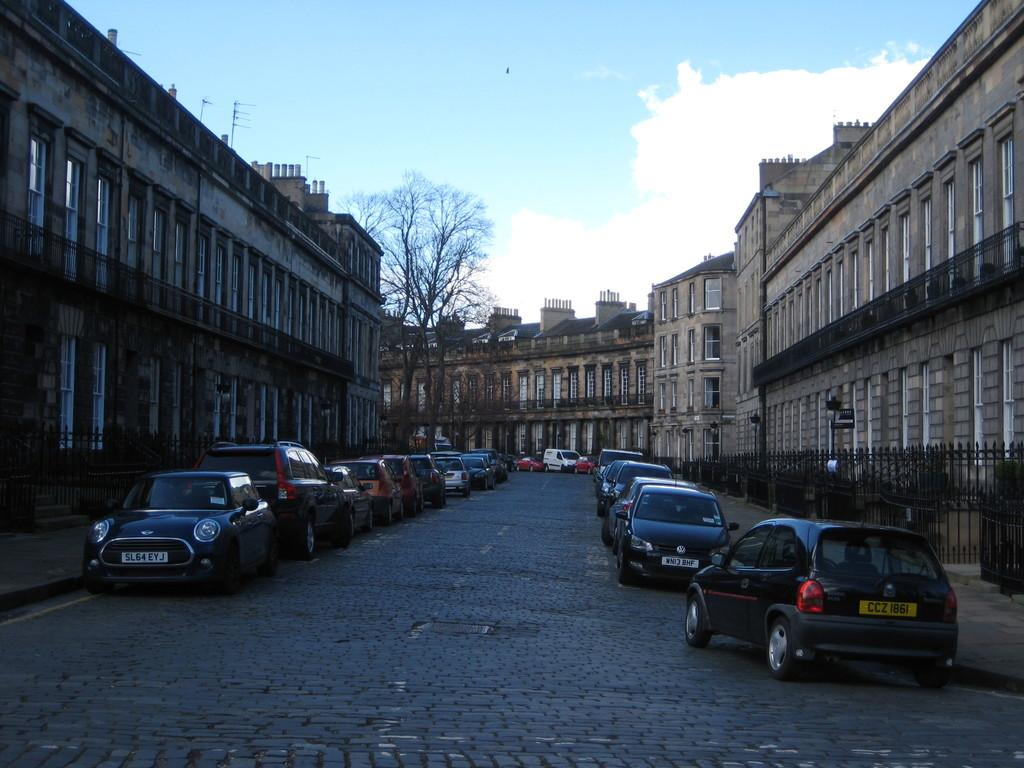What can be seen on the road in the image? There are vehicles on the road in the image. What type of natural elements are present in the image? There are trees in the image. What type of structures can be seen in the image? There are fences and buildings with windows in the image. What else can be found in the image? There are objects in the image. What is visible in the background of the image? The sky with clouds is visible in the background of the image. Can you see any jam being spread on the bridge in the image? There is no jam or bridge present in the image. Are there any people taking a bath in the image? There is no indication of a bath or any people bathing in the image. 